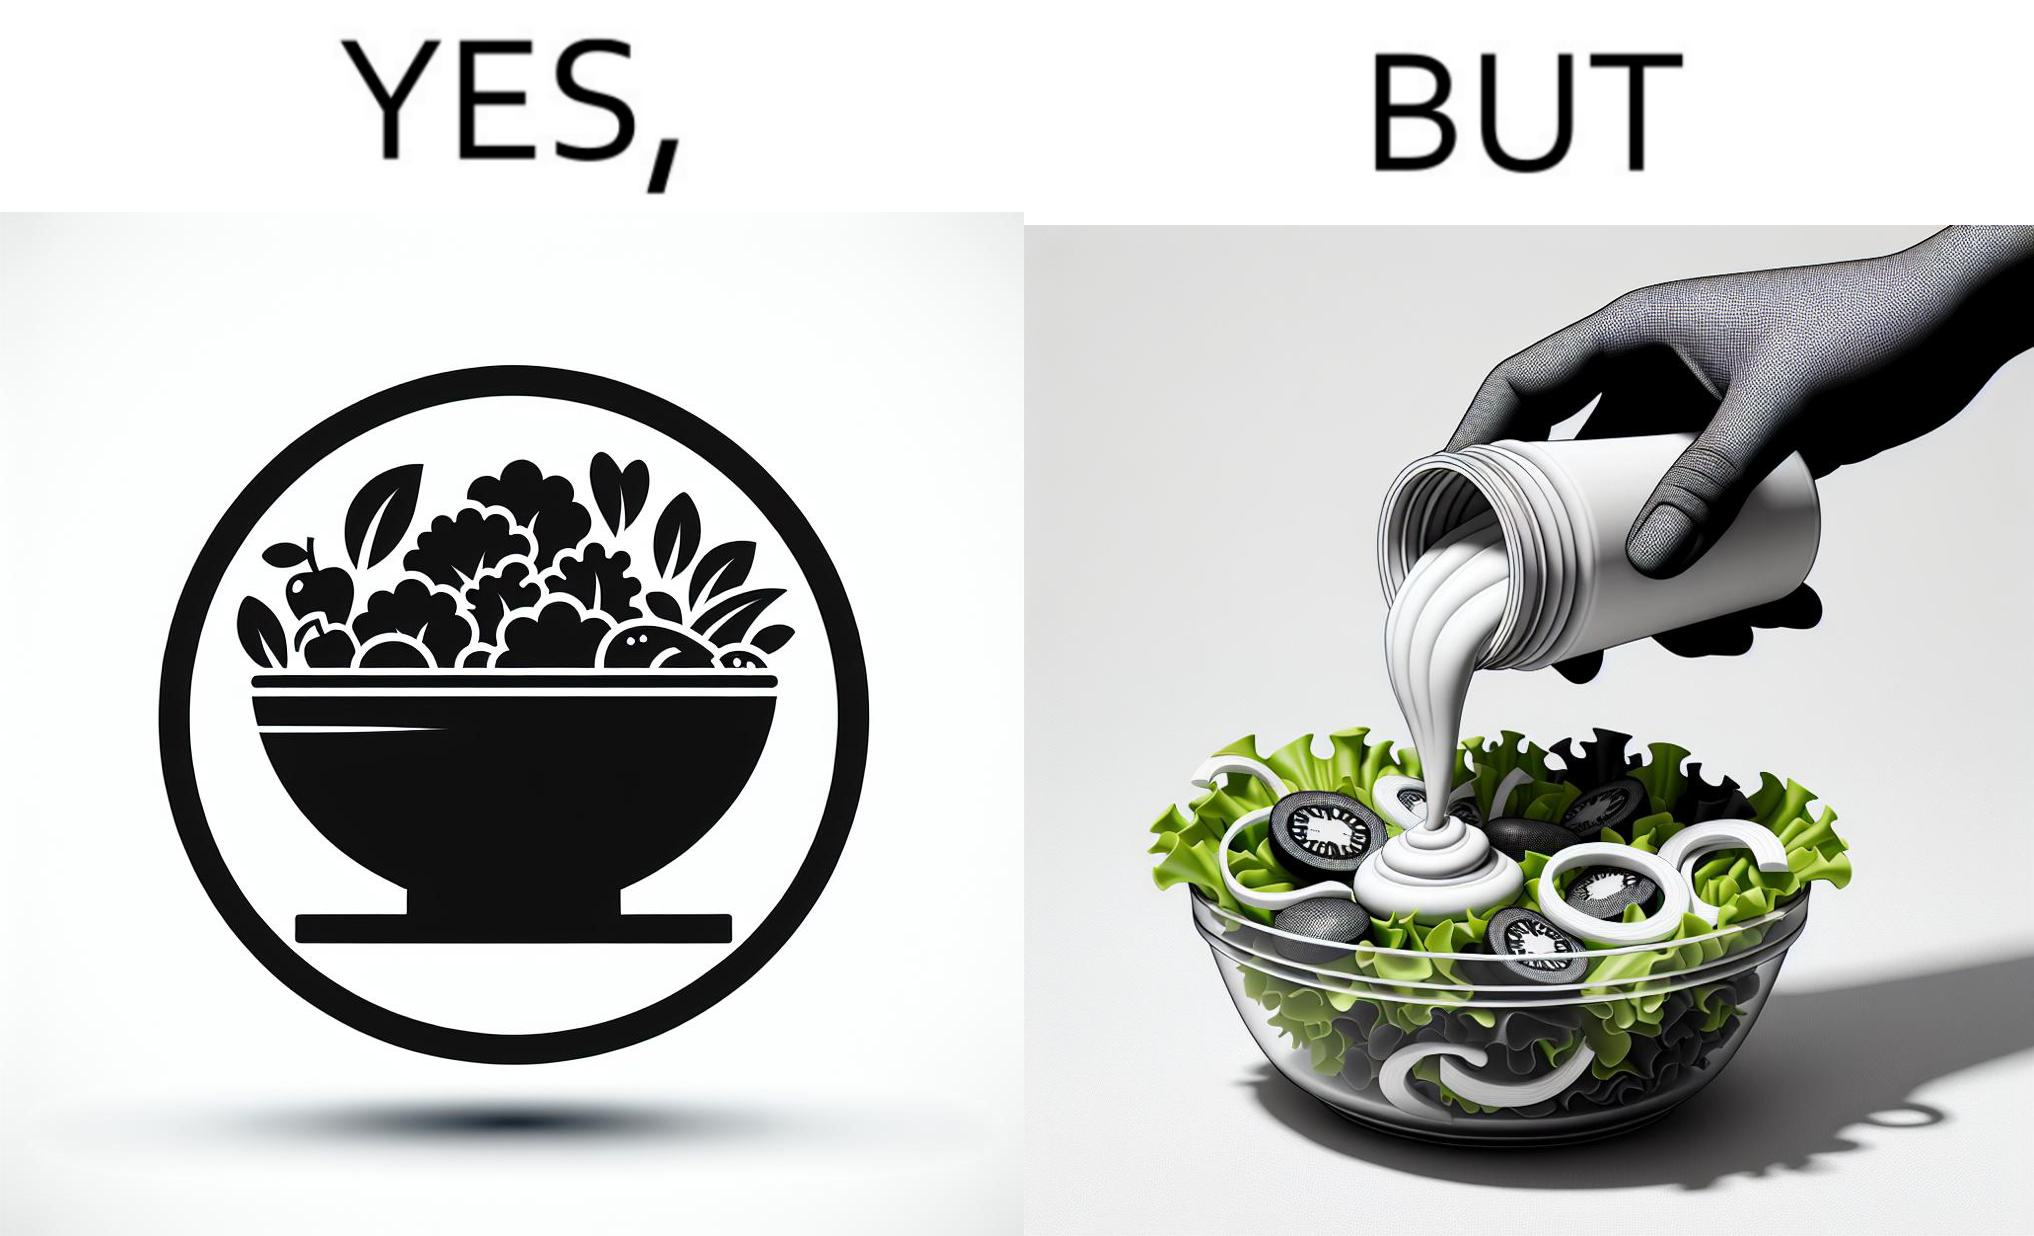What makes this image funny or satirical? The image is ironical, as salad in a bowl by itself is very healthy. However, when people have it with Mayonnaise sauce to improve the taste, it is not healthy anymore, and defeats the point of having nutrient-rich salad altogether. 